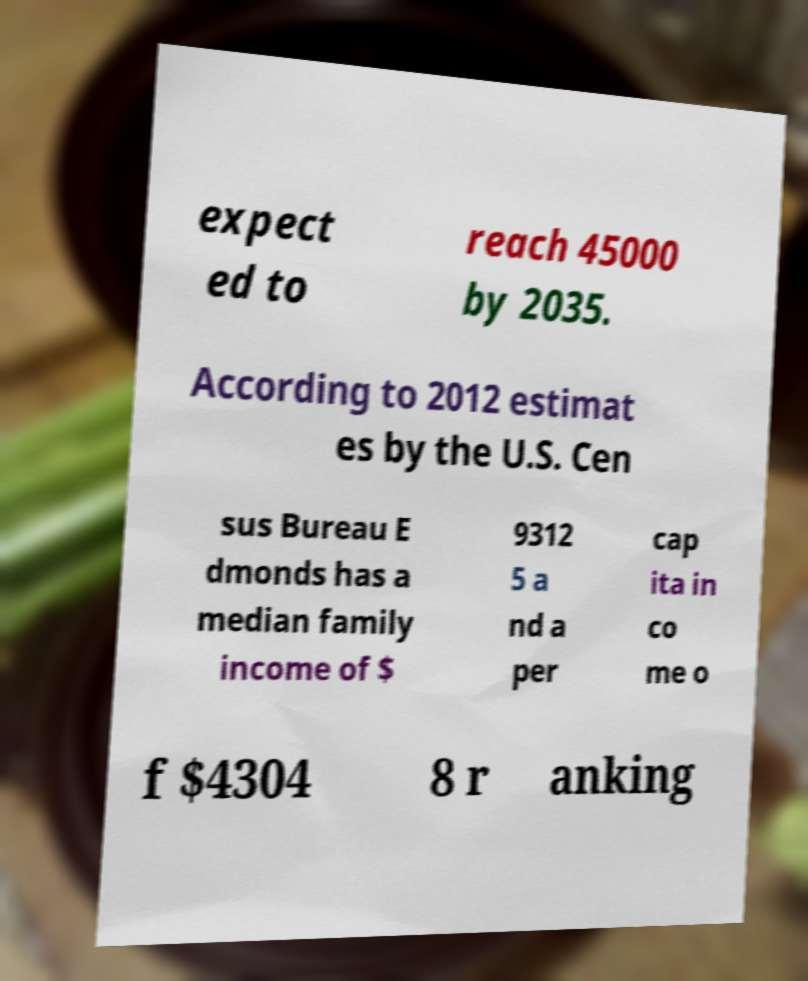Please read and relay the text visible in this image. What does it say? expect ed to reach 45000 by 2035. According to 2012 estimat es by the U.S. Cen sus Bureau E dmonds has a median family income of $ 9312 5 a nd a per cap ita in co me o f $4304 8 r anking 